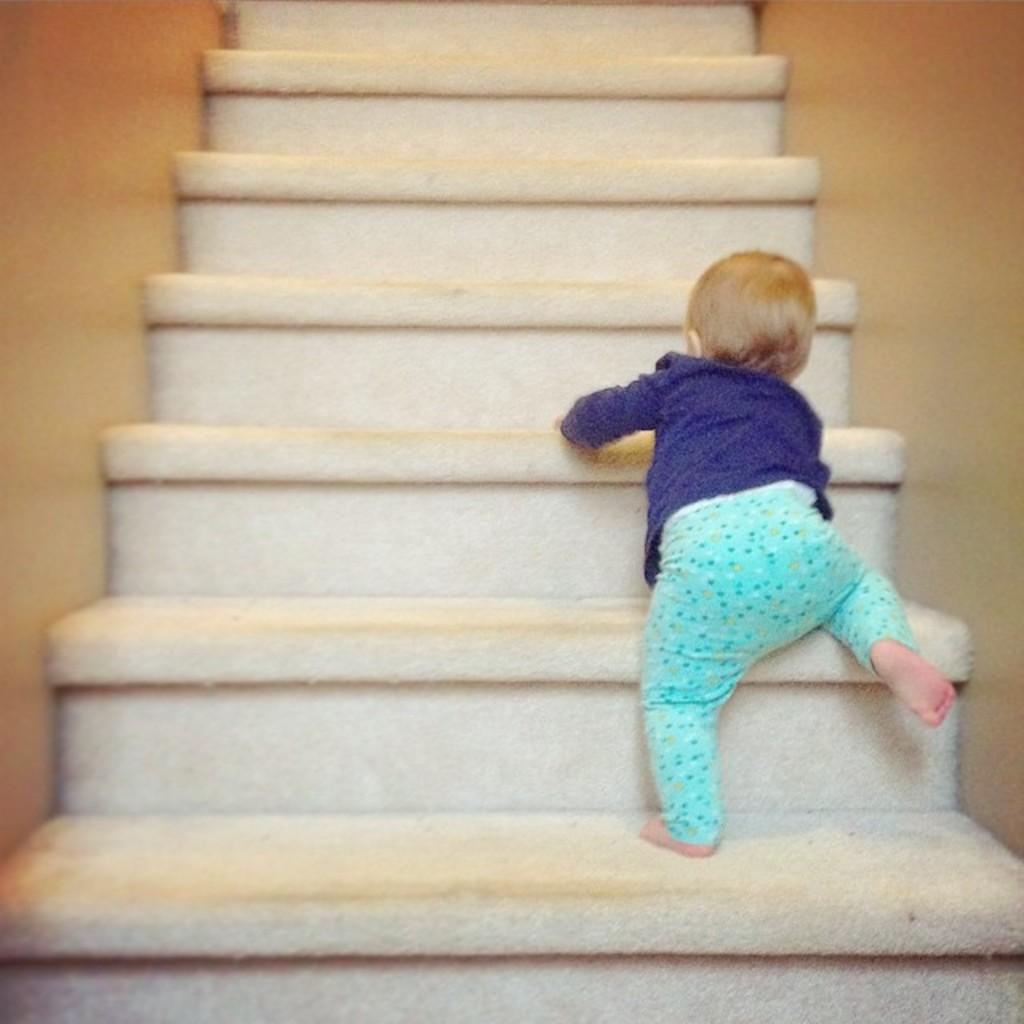What can be seen in the image that people use to move between different levels? There are steps in the image that people use to move between different levels. What is the child in the image doing? The child is climbing the steps. What provides support and structure for the steps in the image? There are walls on the sides of the steps that provide support and structure. What type of grain can be seen growing on the steps in the image? There is no grain visible in the image; the steps are made of a solid material. 